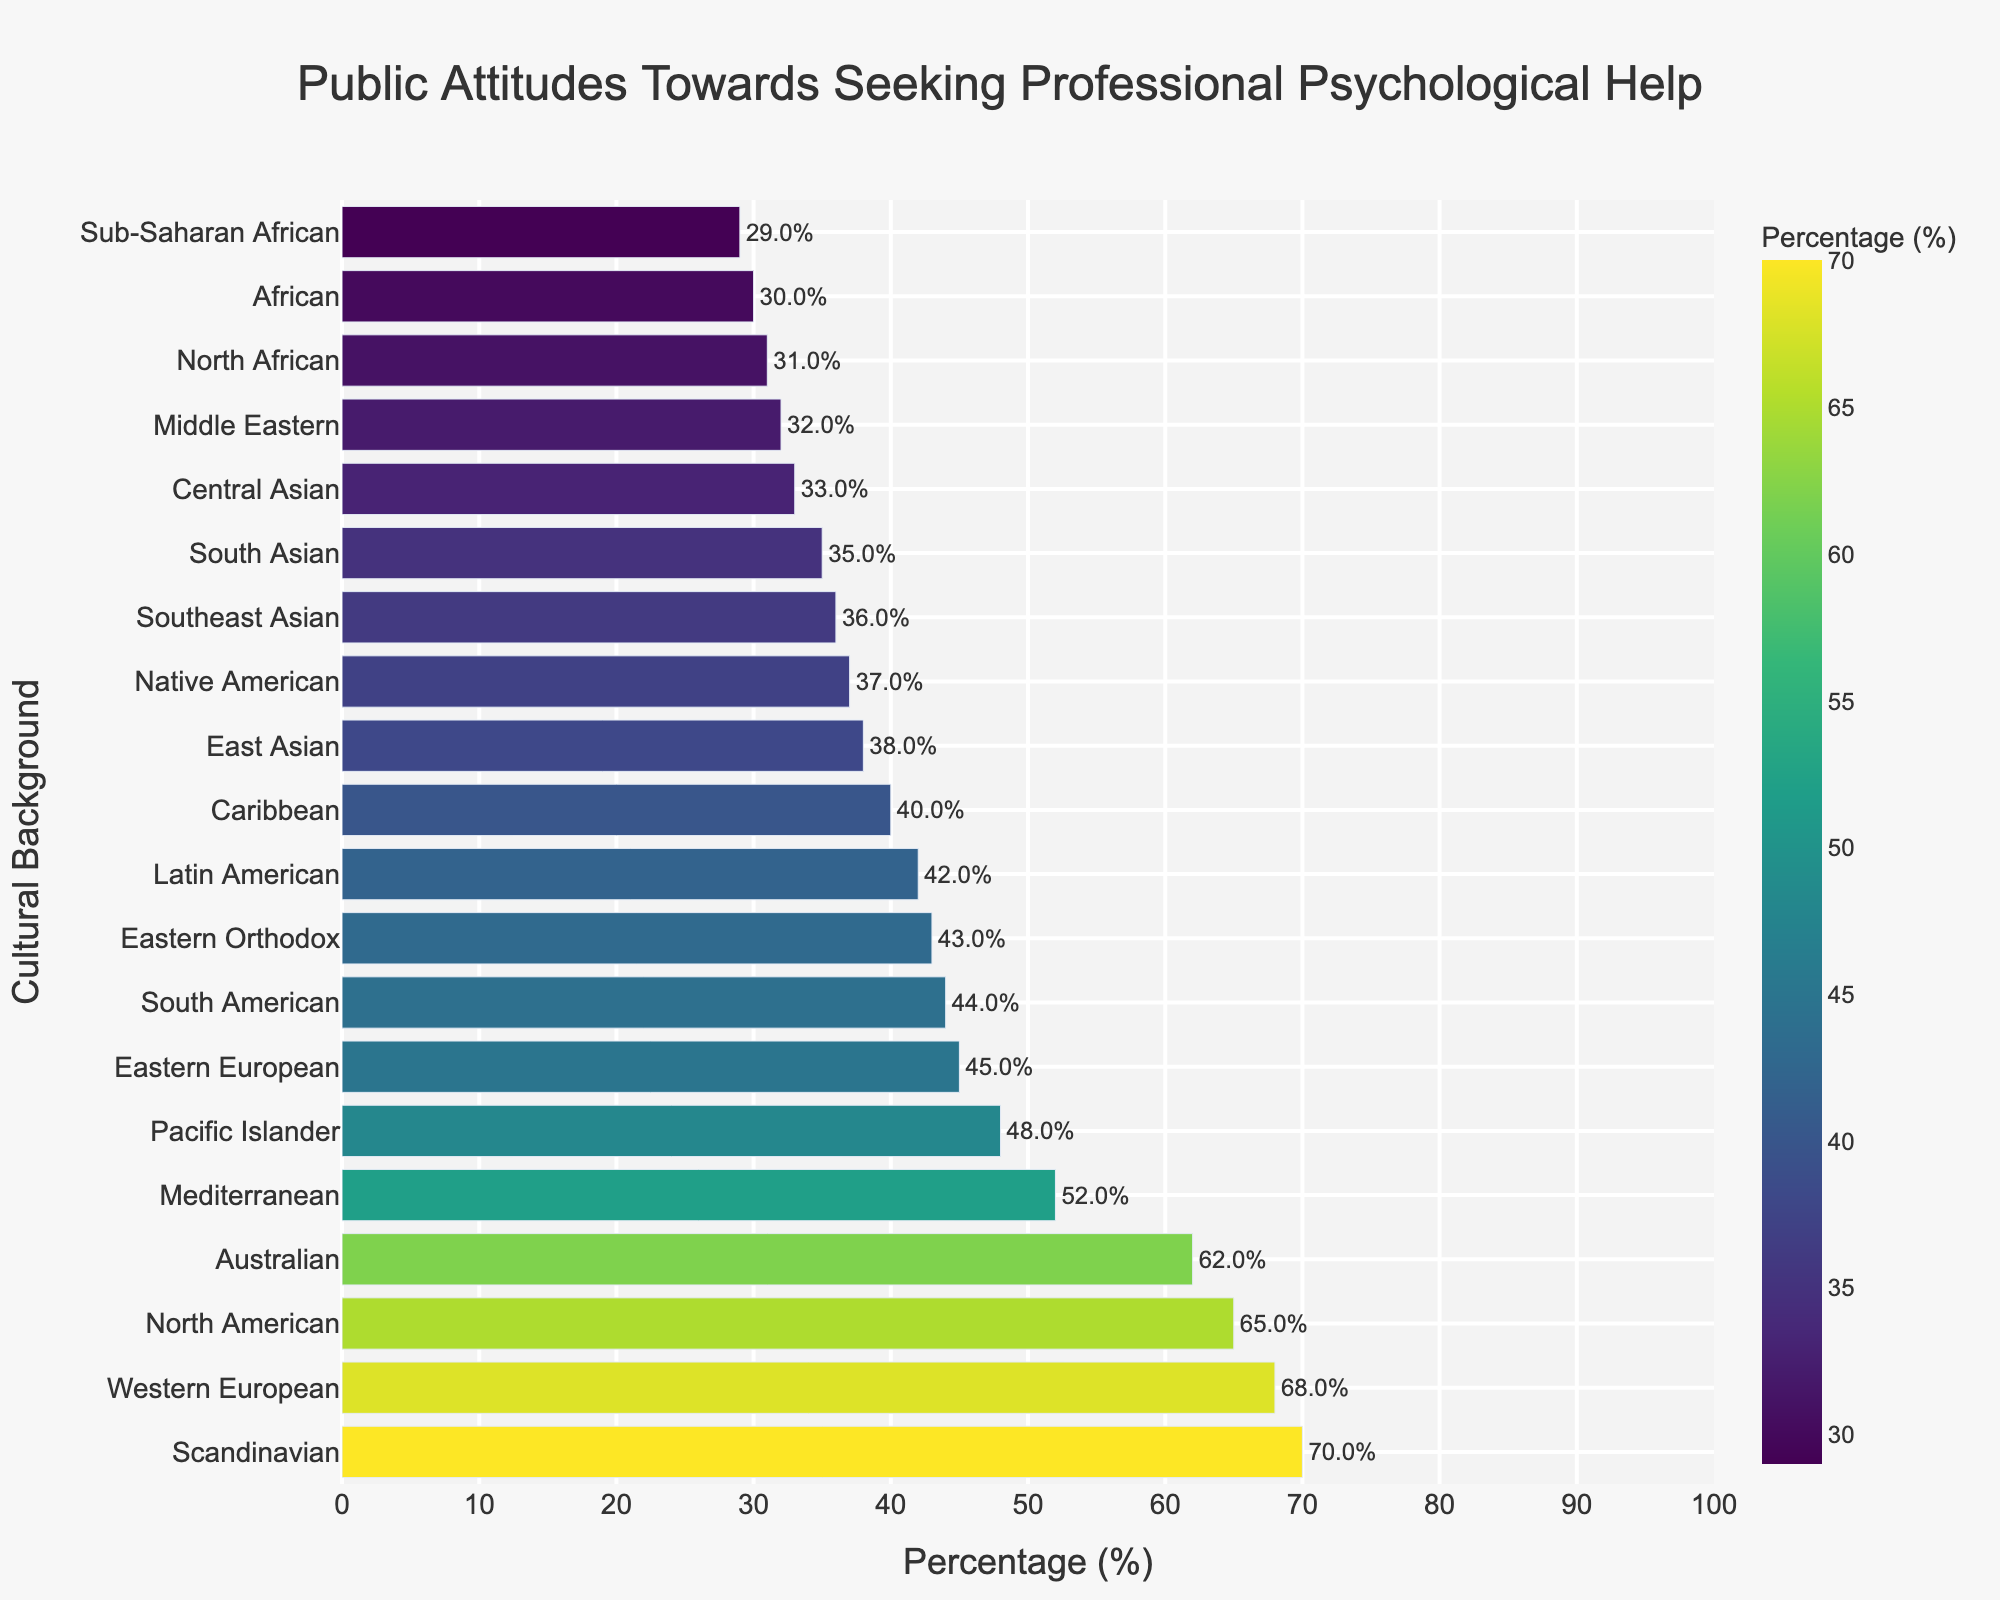What's the difference in percentage between Scandinavian and Sub-Saharan African cultural backgrounds in terms of likelihood to seek professional psychological help? Scandinavian has 70%, and Sub-Saharan African has 29%. The percentage difference between these two is calculated as 70% - 29%.
Answer: 41% Which cultural background has the highest likelihood of seeking professional psychological help? The cultural background observation with the highest bar (70%) is Scandinavian.
Answer: Scandinavian Which cultural backgrounds are more likely to seek help compared to the Southeastern Asian background? Southeast Asian has 36%. The cultures with percentages higher than 36% are Western European, North American, Australian, Mediterranean, Pacific Islander, South American, Eastern Orthodox, Latin American, and Caribbean.
Answer: Western European, North American, Australian, Mediterranean, Pacific Islander, South American, Eastern Orthodox, Latin American, Caribbean What is the average percentage likelihood of seeking help across the Western European, South Asian, and Caribbean cultural backgrounds? Western European is 68%, South Asian is 35%, and Caribbean is 40%. The sum is 68% + 35% + 40% = 143%, and the average is 143%/3.
Answer: 47.7% Are Eastern European and Central Asian public attitudes towards seeking professional psychological help closer to each other than either is to Western European? Eastern European is 45%, Central Asian is 33%, and Western European is 68%. The difference between Eastern European and Central Asian is 45% - 33% = 12%. The differences with Western European are 68% - 45% = 23% and 68% - 33% = 35%.
Answer: Yes What is the median value of percentages likely to seek help across all cultural backgrounds listed? The sorted list of percentages is 29, 30, 31, 32, 33, 35, 36, 37, 38, 40, 42, 43, 44, 45, 48, 52, 62, 65, 68, 70. With 20 data points, the median will be the average of the 10th and 11th values: (40+42)/2 = 41%.
Answer: 41% Which cultural background shows a higher likelihood to seek help, Eastern Orthodox or Latin American? Eastern Orthodox has 43%, and Latin American has 42%. The bar corresponding to 43% is higher than that of 42%.
Answer: Eastern Orthodox How many cultural backgrounds have a percentage likelihood to seek help below 40%? The count includes East Asian (38%), South Asian (35%), Middle Eastern (32%), African (30%), Southeast Asian (36%), Native American (37%), Central Asian (33%), North African (31%), Sub-Saharan African (29%), totaling 9 cultures.
Answer: 9 